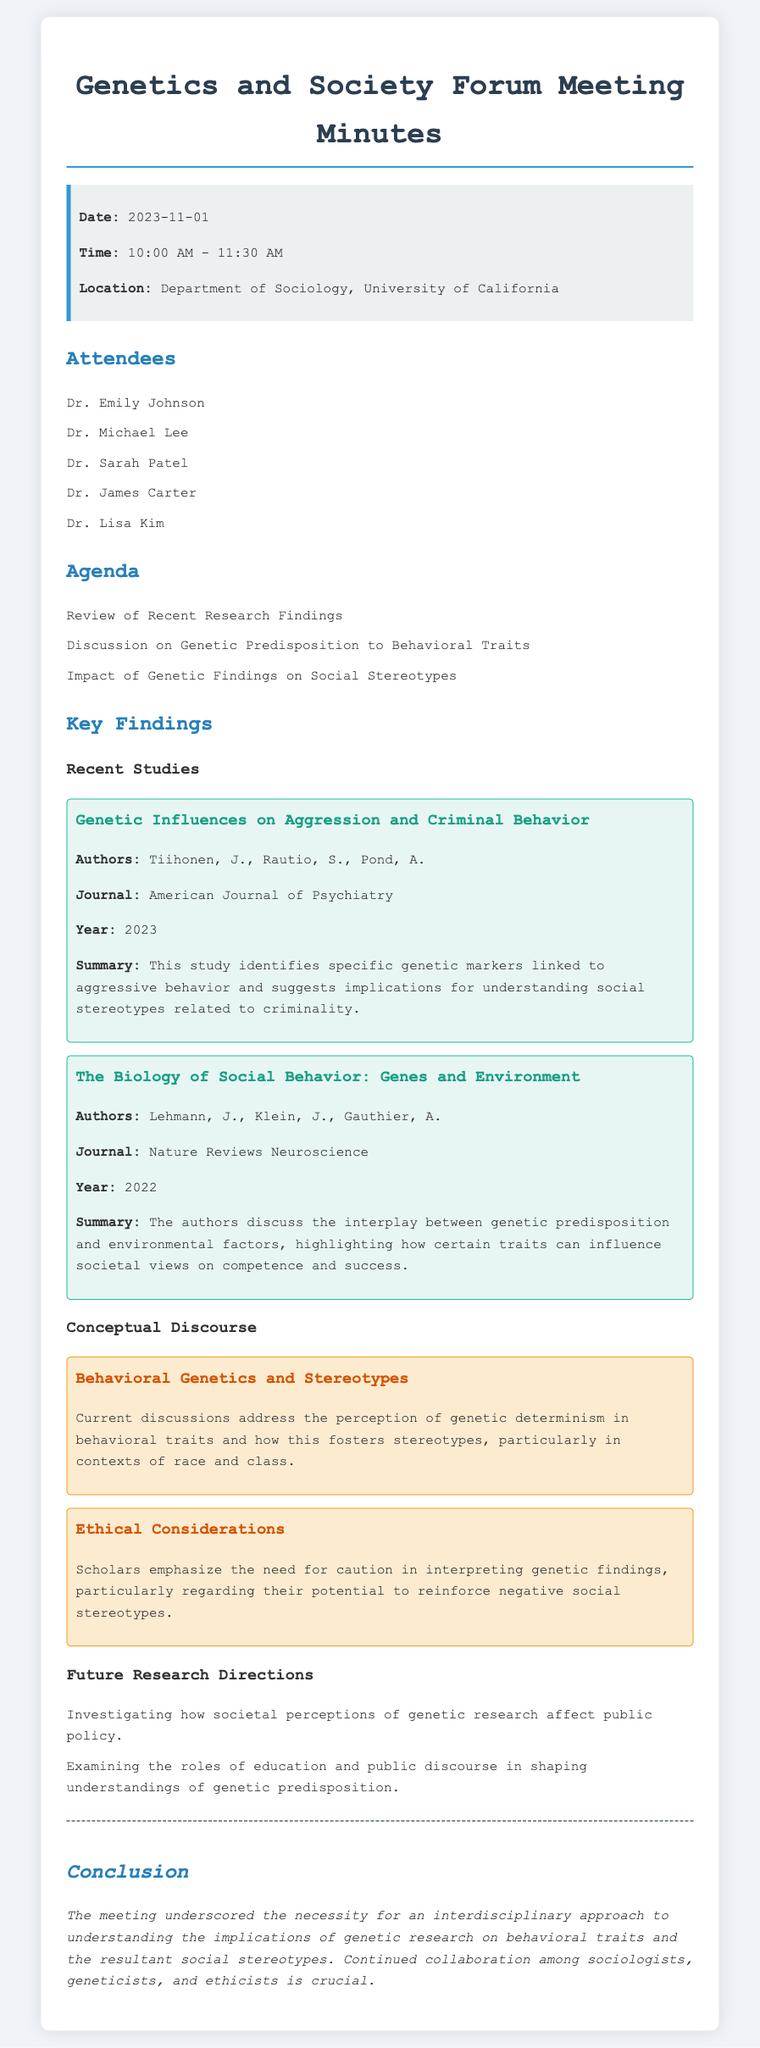what is the date of the meeting? The date of the meeting is specified in the info box at the top of the document.
Answer: 2023-11-01 who are the authors of the study titled "Genetic Influences on Aggression and Criminal Behavior"? The authors of this study are listed in the related section of the document.
Answer: Tiihonen, J., Rautio, S., Pond, A which journal published the study on social behavior and genetics? The journal in which the study was published is mentioned directly under the study summary.
Answer: Nature Reviews Neuroscience what is one key finding from the study discussed in the meeting? This answer is derived from the summaries of the research studies included in the document.
Answer: Specific genetic markers linked to aggressive behavior how do genetic findings impact societal views according to the studies? This question requires reasoning about the content of the studies discussed in relation to social stereotypes.
Answer: They can influence societal views on competence and success what ethical concern is highlighted in the conclusions of the meeting? This is mentioned under the section discussing ethical considerations in the meeting minutes.
Answer: Reinforce negative social stereotypes how many attendees were listed in the meeting minutes? The number of attendees is counted from the list provided in the document.
Answer: 5 what is the main focus of future research directions? The focus is specified in the last section of the document outlining future research topics.
Answer: Societal perceptions of genetic research who organized the forum meeting? The organizer is implicit in the hosting of the event, which is inferred from the context of the meeting on genetics and society.
Answer: Department of Sociology, University of California 